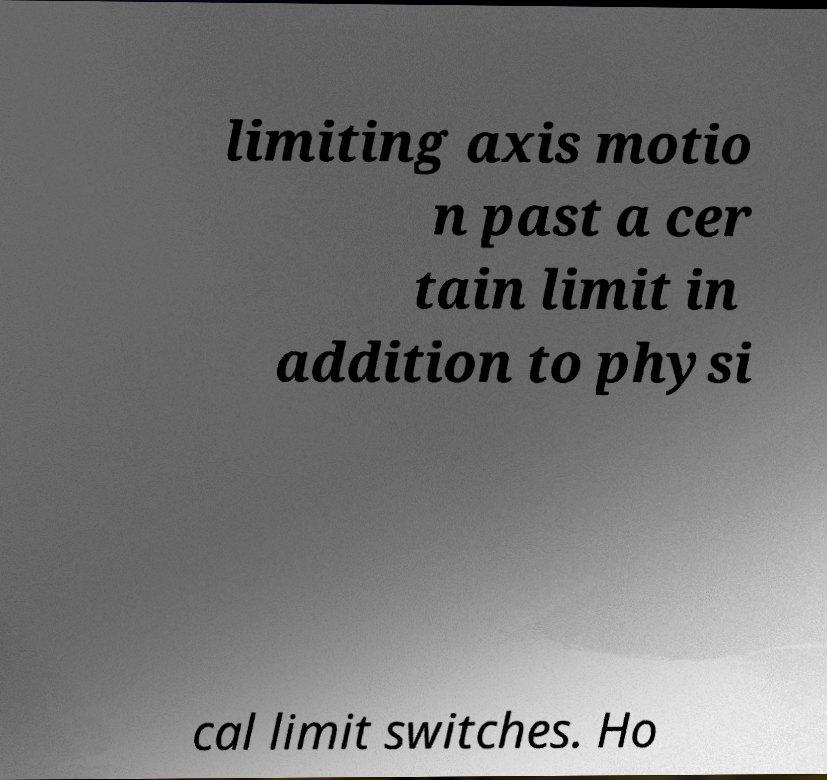Can you accurately transcribe the text from the provided image for me? limiting axis motio n past a cer tain limit in addition to physi cal limit switches. Ho 